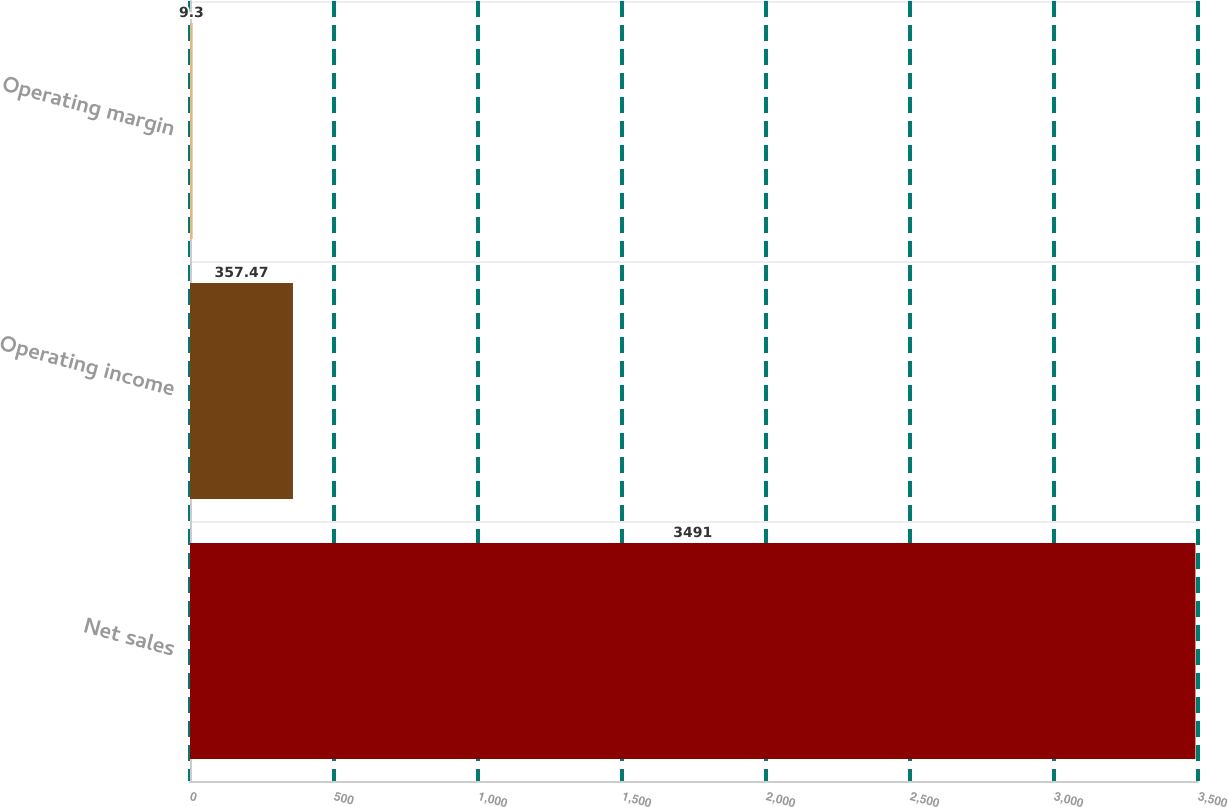Convert chart to OTSL. <chart><loc_0><loc_0><loc_500><loc_500><bar_chart><fcel>Net sales<fcel>Operating income<fcel>Operating margin<nl><fcel>3491<fcel>357.47<fcel>9.3<nl></chart> 